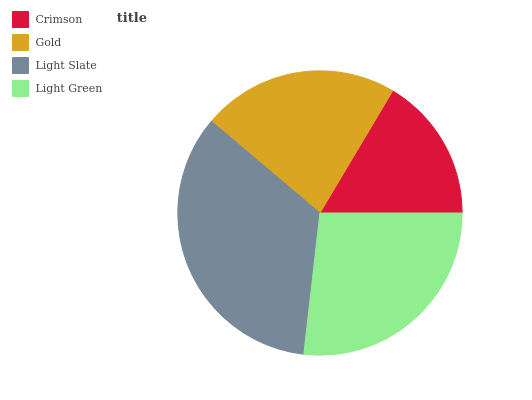Is Crimson the minimum?
Answer yes or no. Yes. Is Light Slate the maximum?
Answer yes or no. Yes. Is Gold the minimum?
Answer yes or no. No. Is Gold the maximum?
Answer yes or no. No. Is Gold greater than Crimson?
Answer yes or no. Yes. Is Crimson less than Gold?
Answer yes or no. Yes. Is Crimson greater than Gold?
Answer yes or no. No. Is Gold less than Crimson?
Answer yes or no. No. Is Light Green the high median?
Answer yes or no. Yes. Is Gold the low median?
Answer yes or no. Yes. Is Gold the high median?
Answer yes or no. No. Is Light Slate the low median?
Answer yes or no. No. 